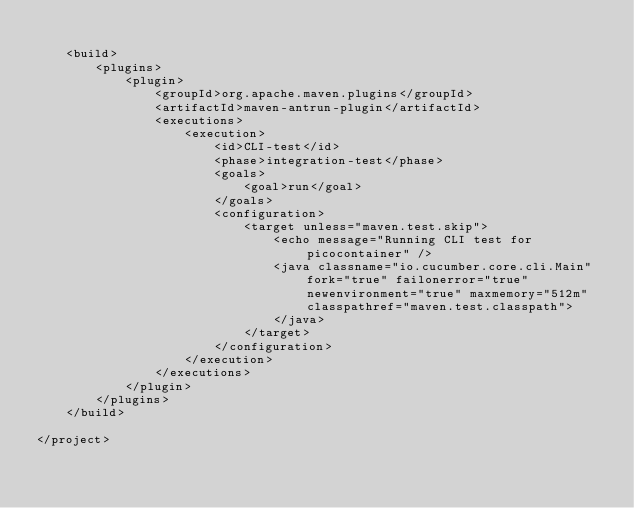Convert code to text. <code><loc_0><loc_0><loc_500><loc_500><_XML_>
    <build>
        <plugins>
            <plugin>
                <groupId>org.apache.maven.plugins</groupId>
                <artifactId>maven-antrun-plugin</artifactId>
                <executions>
                    <execution>
                        <id>CLI-test</id>
                        <phase>integration-test</phase>
                        <goals>
                            <goal>run</goal>
                        </goals>
                        <configuration>
                            <target unless="maven.test.skip">
                                <echo message="Running CLI test for picocontainer" />
                                <java classname="io.cucumber.core.cli.Main" fork="true" failonerror="true" newenvironment="true" maxmemory="512m" classpathref="maven.test.classpath">
                                </java>
                            </target>
                        </configuration>
                    </execution>
                </executions>
            </plugin>
        </plugins>
    </build>

</project>
</code> 